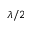<formula> <loc_0><loc_0><loc_500><loc_500>\lambda / { 2 }</formula> 